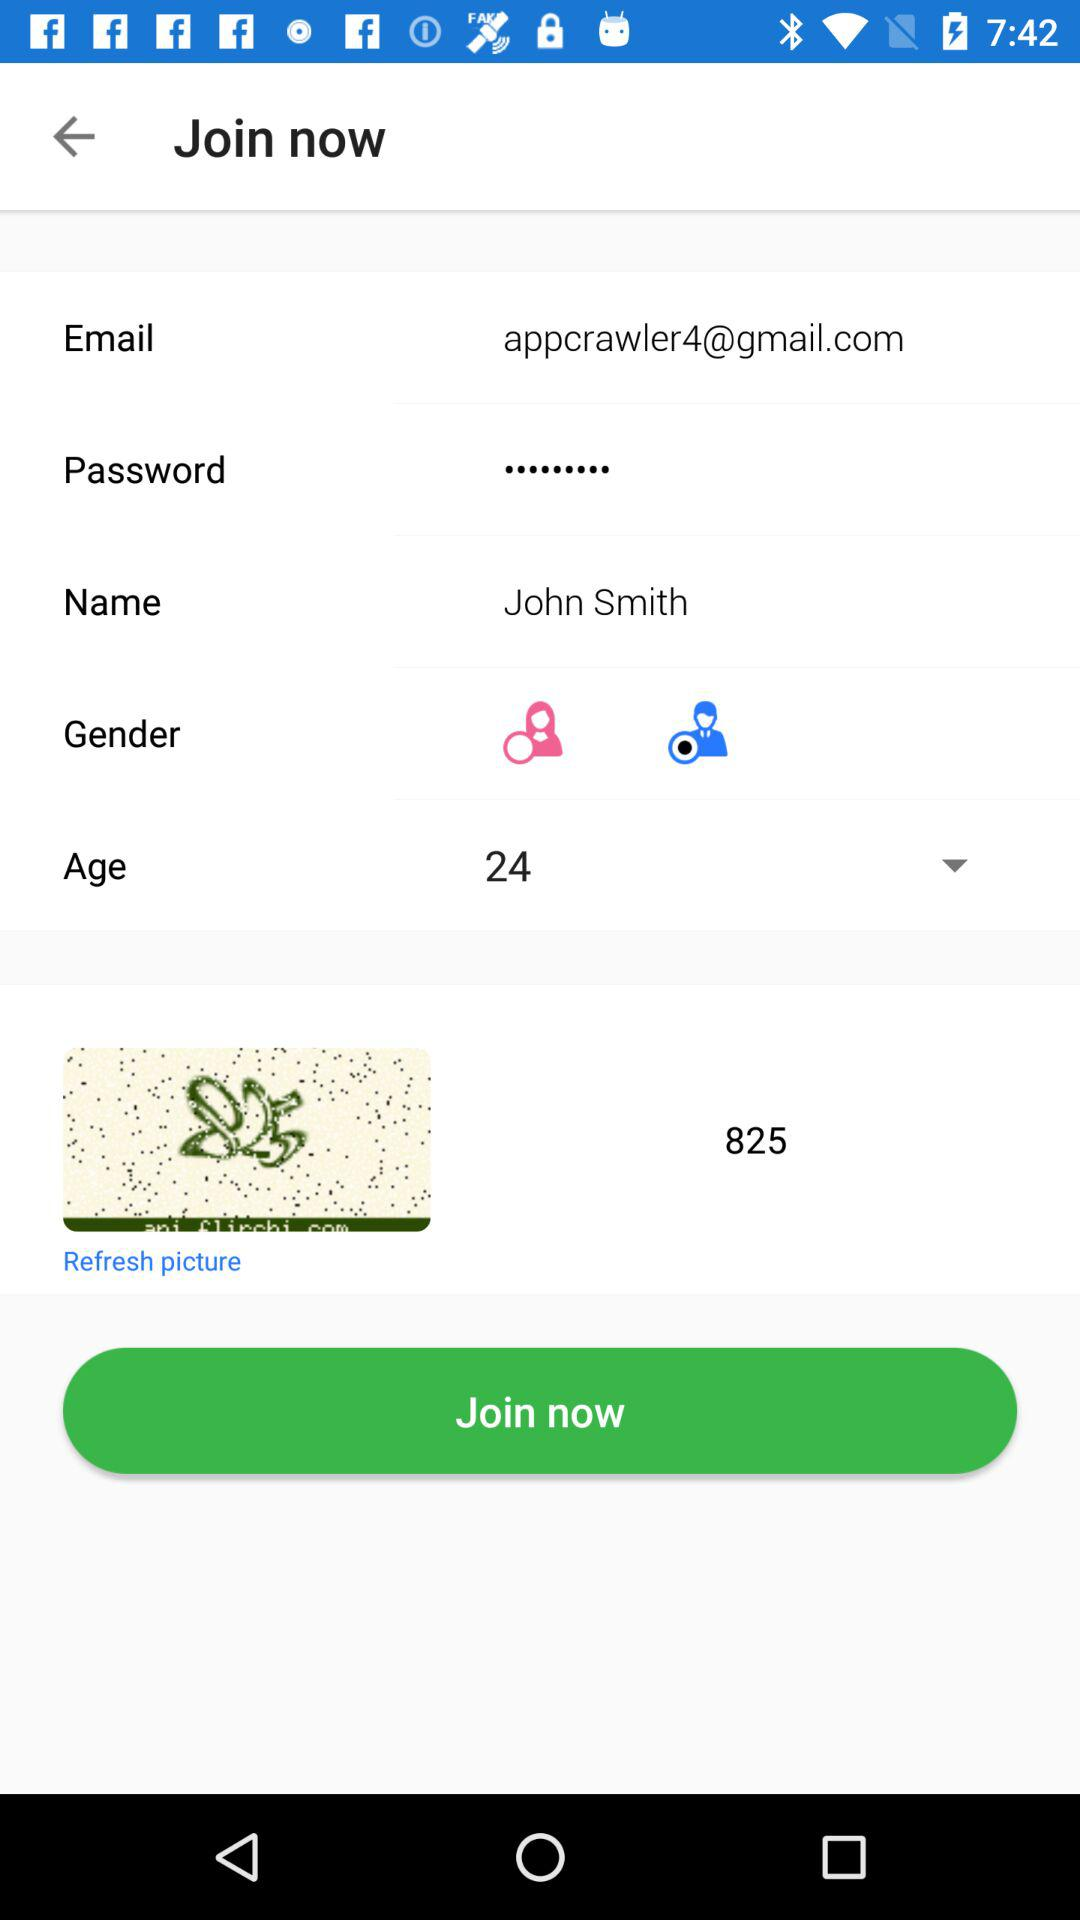What is the age of the user? The age of the user is 24. 